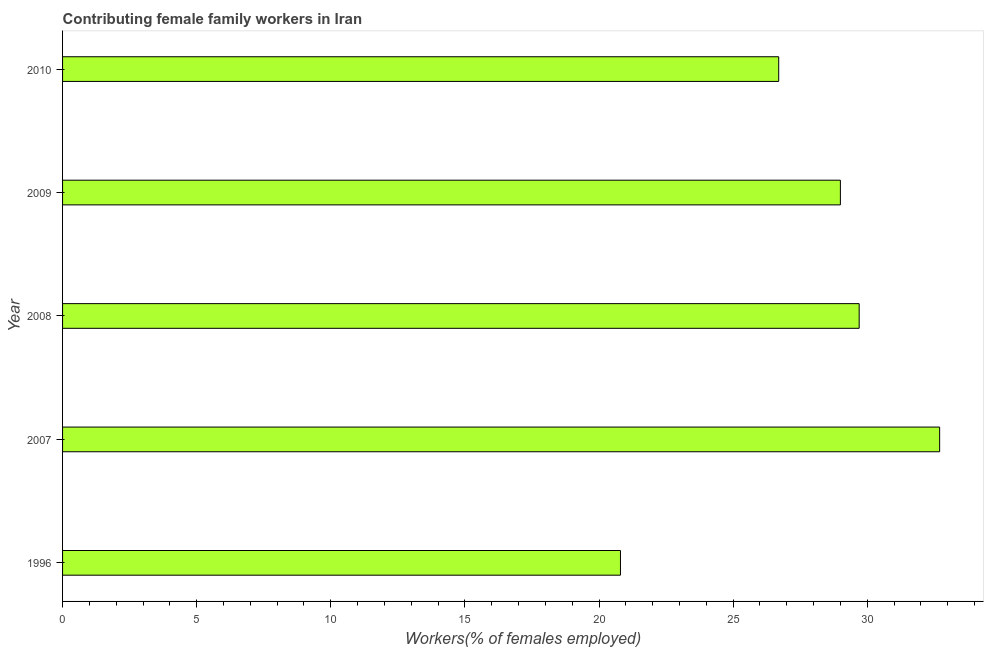Does the graph contain any zero values?
Your response must be concise. No. Does the graph contain grids?
Your response must be concise. No. What is the title of the graph?
Provide a succinct answer. Contributing female family workers in Iran. What is the label or title of the X-axis?
Keep it short and to the point. Workers(% of females employed). What is the contributing female family workers in 2008?
Your answer should be very brief. 29.7. Across all years, what is the maximum contributing female family workers?
Your response must be concise. 32.7. Across all years, what is the minimum contributing female family workers?
Your response must be concise. 20.8. In which year was the contributing female family workers minimum?
Provide a short and direct response. 1996. What is the sum of the contributing female family workers?
Provide a succinct answer. 138.9. What is the difference between the contributing female family workers in 2007 and 2008?
Offer a very short reply. 3. What is the average contributing female family workers per year?
Give a very brief answer. 27.78. What is the median contributing female family workers?
Ensure brevity in your answer.  29. Do a majority of the years between 2008 and 2007 (inclusive) have contributing female family workers greater than 13 %?
Make the answer very short. No. What is the ratio of the contributing female family workers in 2009 to that in 2010?
Offer a terse response. 1.09. Is the difference between the contributing female family workers in 2007 and 2010 greater than the difference between any two years?
Ensure brevity in your answer.  No. How many bars are there?
Your response must be concise. 5. What is the difference between two consecutive major ticks on the X-axis?
Offer a terse response. 5. Are the values on the major ticks of X-axis written in scientific E-notation?
Make the answer very short. No. What is the Workers(% of females employed) in 1996?
Make the answer very short. 20.8. What is the Workers(% of females employed) of 2007?
Your response must be concise. 32.7. What is the Workers(% of females employed) of 2008?
Your answer should be compact. 29.7. What is the Workers(% of females employed) in 2010?
Offer a very short reply. 26.7. What is the difference between the Workers(% of females employed) in 1996 and 2008?
Offer a very short reply. -8.9. What is the difference between the Workers(% of females employed) in 1996 and 2009?
Your response must be concise. -8.2. What is the difference between the Workers(% of females employed) in 1996 and 2010?
Make the answer very short. -5.9. What is the difference between the Workers(% of females employed) in 2008 and 2009?
Give a very brief answer. 0.7. What is the difference between the Workers(% of females employed) in 2009 and 2010?
Your response must be concise. 2.3. What is the ratio of the Workers(% of females employed) in 1996 to that in 2007?
Your response must be concise. 0.64. What is the ratio of the Workers(% of females employed) in 1996 to that in 2008?
Ensure brevity in your answer.  0.7. What is the ratio of the Workers(% of females employed) in 1996 to that in 2009?
Your response must be concise. 0.72. What is the ratio of the Workers(% of females employed) in 1996 to that in 2010?
Give a very brief answer. 0.78. What is the ratio of the Workers(% of females employed) in 2007 to that in 2008?
Provide a short and direct response. 1.1. What is the ratio of the Workers(% of females employed) in 2007 to that in 2009?
Your response must be concise. 1.13. What is the ratio of the Workers(% of females employed) in 2007 to that in 2010?
Your answer should be compact. 1.23. What is the ratio of the Workers(% of females employed) in 2008 to that in 2009?
Your answer should be very brief. 1.02. What is the ratio of the Workers(% of females employed) in 2008 to that in 2010?
Your answer should be very brief. 1.11. What is the ratio of the Workers(% of females employed) in 2009 to that in 2010?
Provide a succinct answer. 1.09. 